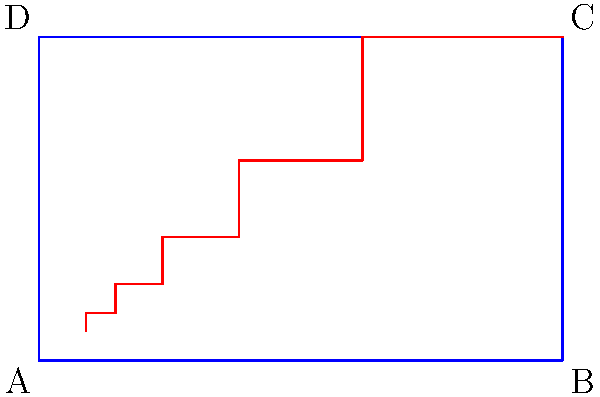In the diagram above, a golden rectangle ABCD is shown with a spiral overlay. This representation is often used to analyze composition in famous artworks. If the length of the shorter side of the rectangle is 1 unit, what is the length of the longer side? To find the length of the longer side of the golden rectangle, we need to understand the properties of the golden ratio:

1. The golden ratio, denoted by $\phi$ (phi), is approximately equal to 1.618033988749895.

2. In a golden rectangle, the ratio of the longer side to the shorter side is equal to $\phi$.

3. The golden ratio is defined mathematically as:

   $\phi = \frac{1 + \sqrt{5}}{2}$

4. Given that the shorter side of the rectangle is 1 unit, we can set up the following equation:

   $\frac{\text{longer side}}{1} = \phi$

5. Therefore, the length of the longer side is simply equal to $\phi$.

6. We can calculate this value:

   $\phi = \frac{1 + \sqrt{5}}{2} \approx 1.618033988749895$

So, the length of the longer side of the golden rectangle is approximately 1.618033988749895 units.
Answer: $\phi \approx 1.618033988749895$ 